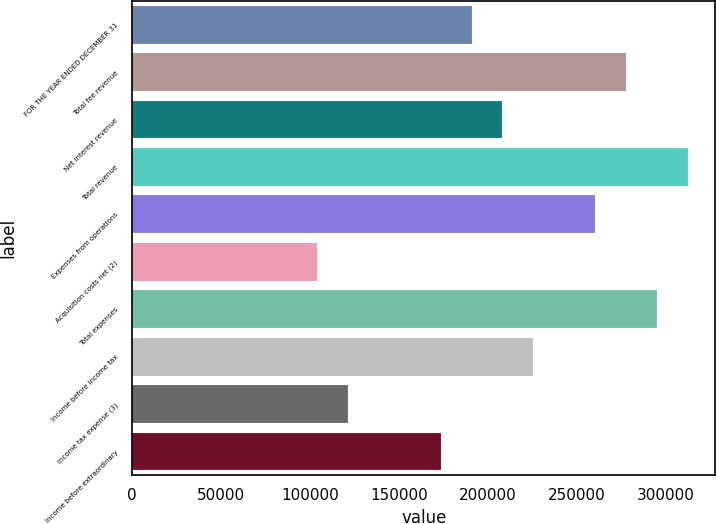<chart> <loc_0><loc_0><loc_500><loc_500><bar_chart><fcel>FOR THE YEAR ENDED DECEMBER 31<fcel>Total fee revenue<fcel>Net interest revenue<fcel>Total revenue<fcel>Expenses from operations<fcel>Acquisition costs net (2)<fcel>Total expenses<fcel>Income before income tax<fcel>Income tax expense (3)<fcel>Income before extraordinary<nl><fcel>190994<fcel>277809<fcel>208357<fcel>312535<fcel>260446<fcel>104179<fcel>295172<fcel>225720<fcel>121542<fcel>173631<nl></chart> 